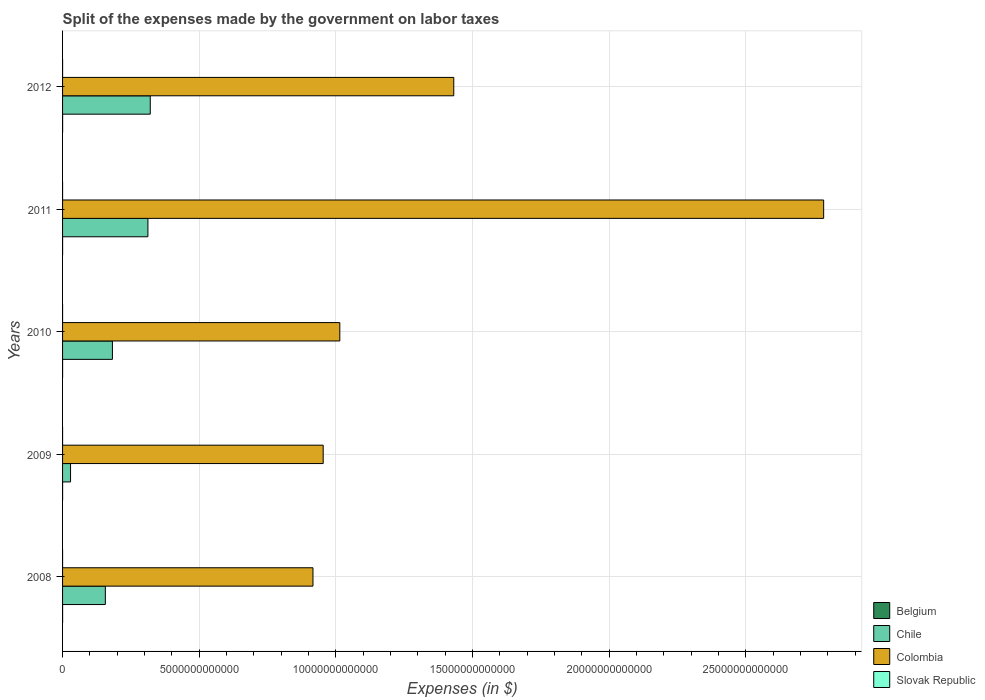Are the number of bars per tick equal to the number of legend labels?
Provide a short and direct response. Yes. Are the number of bars on each tick of the Y-axis equal?
Your response must be concise. Yes. How many bars are there on the 2nd tick from the bottom?
Make the answer very short. 4. What is the expenses made by the government on labor taxes in Chile in 2011?
Offer a very short reply. 3.12e+12. Across all years, what is the maximum expenses made by the government on labor taxes in Slovak Republic?
Your answer should be compact. 2.40e+08. Across all years, what is the minimum expenses made by the government on labor taxes in Slovak Republic?
Your answer should be very brief. 3.61e+05. In which year was the expenses made by the government on labor taxes in Slovak Republic minimum?
Make the answer very short. 2010. What is the total expenses made by the government on labor taxes in Colombia in the graph?
Offer a very short reply. 7.10e+13. What is the difference between the expenses made by the government on labor taxes in Belgium in 2009 and that in 2011?
Give a very brief answer. -1.00e+08. What is the difference between the expenses made by the government on labor taxes in Belgium in 2009 and the expenses made by the government on labor taxes in Colombia in 2011?
Offer a terse response. -2.78e+13. What is the average expenses made by the government on labor taxes in Slovak Republic per year?
Offer a terse response. 5.68e+07. In the year 2011, what is the difference between the expenses made by the government on labor taxes in Slovak Republic and expenses made by the government on labor taxes in Chile?
Make the answer very short. -3.12e+12. In how many years, is the expenses made by the government on labor taxes in Colombia greater than 2000000000000 $?
Your answer should be compact. 5. What is the ratio of the expenses made by the government on labor taxes in Colombia in 2008 to that in 2009?
Give a very brief answer. 0.96. Is the difference between the expenses made by the government on labor taxes in Slovak Republic in 2009 and 2010 greater than the difference between the expenses made by the government on labor taxes in Chile in 2009 and 2010?
Give a very brief answer. Yes. What is the difference between the highest and the second highest expenses made by the government on labor taxes in Colombia?
Offer a very short reply. 1.35e+13. What is the difference between the highest and the lowest expenses made by the government on labor taxes in Chile?
Your answer should be very brief. 2.92e+12. In how many years, is the expenses made by the government on labor taxes in Colombia greater than the average expenses made by the government on labor taxes in Colombia taken over all years?
Provide a succinct answer. 2. Is the sum of the expenses made by the government on labor taxes in Colombia in 2009 and 2010 greater than the maximum expenses made by the government on labor taxes in Slovak Republic across all years?
Offer a very short reply. Yes. Is it the case that in every year, the sum of the expenses made by the government on labor taxes in Slovak Republic and expenses made by the government on labor taxes in Colombia is greater than the sum of expenses made by the government on labor taxes in Belgium and expenses made by the government on labor taxes in Chile?
Your answer should be very brief. Yes. What does the 3rd bar from the top in 2011 represents?
Your response must be concise. Chile. Are all the bars in the graph horizontal?
Give a very brief answer. Yes. How many years are there in the graph?
Offer a terse response. 5. What is the difference between two consecutive major ticks on the X-axis?
Offer a very short reply. 5.00e+12. Are the values on the major ticks of X-axis written in scientific E-notation?
Your answer should be compact. No. How are the legend labels stacked?
Offer a very short reply. Vertical. What is the title of the graph?
Your answer should be compact. Split of the expenses made by the government on labor taxes. Does "United Kingdom" appear as one of the legend labels in the graph?
Provide a succinct answer. No. What is the label or title of the X-axis?
Your answer should be compact. Expenses (in $). What is the Expenses (in $) of Belgium in 2008?
Your response must be concise. 1.14e+09. What is the Expenses (in $) of Chile in 2008?
Ensure brevity in your answer.  1.57e+12. What is the Expenses (in $) in Colombia in 2008?
Keep it short and to the point. 9.16e+12. What is the Expenses (in $) of Slovak Republic in 2008?
Offer a terse response. 1.39e+06. What is the Expenses (in $) of Belgium in 2009?
Give a very brief answer. 1.05e+09. What is the Expenses (in $) of Chile in 2009?
Ensure brevity in your answer.  2.92e+11. What is the Expenses (in $) of Colombia in 2009?
Keep it short and to the point. 9.54e+12. What is the Expenses (in $) of Slovak Republic in 2009?
Keep it short and to the point. 7.25e+05. What is the Expenses (in $) in Belgium in 2010?
Your response must be concise. 1.13e+09. What is the Expenses (in $) in Chile in 2010?
Provide a succinct answer. 1.82e+12. What is the Expenses (in $) of Colombia in 2010?
Give a very brief answer. 1.01e+13. What is the Expenses (in $) in Slovak Republic in 2010?
Offer a terse response. 3.61e+05. What is the Expenses (in $) of Belgium in 2011?
Provide a succinct answer. 1.15e+09. What is the Expenses (in $) of Chile in 2011?
Your answer should be compact. 3.12e+12. What is the Expenses (in $) in Colombia in 2011?
Your answer should be compact. 2.78e+13. What is the Expenses (in $) in Slovak Republic in 2011?
Your response must be concise. 4.13e+07. What is the Expenses (in $) in Belgium in 2012?
Your response must be concise. 1.84e+09. What is the Expenses (in $) in Chile in 2012?
Your answer should be compact. 3.21e+12. What is the Expenses (in $) of Colombia in 2012?
Your answer should be very brief. 1.43e+13. What is the Expenses (in $) in Slovak Republic in 2012?
Offer a very short reply. 2.40e+08. Across all years, what is the maximum Expenses (in $) in Belgium?
Provide a succinct answer. 1.84e+09. Across all years, what is the maximum Expenses (in $) of Chile?
Offer a terse response. 3.21e+12. Across all years, what is the maximum Expenses (in $) of Colombia?
Ensure brevity in your answer.  2.78e+13. Across all years, what is the maximum Expenses (in $) in Slovak Republic?
Your response must be concise. 2.40e+08. Across all years, what is the minimum Expenses (in $) in Belgium?
Your answer should be very brief. 1.05e+09. Across all years, what is the minimum Expenses (in $) in Chile?
Your answer should be very brief. 2.92e+11. Across all years, what is the minimum Expenses (in $) of Colombia?
Your answer should be very brief. 9.16e+12. Across all years, what is the minimum Expenses (in $) of Slovak Republic?
Ensure brevity in your answer.  3.61e+05. What is the total Expenses (in $) of Belgium in the graph?
Offer a very short reply. 6.31e+09. What is the total Expenses (in $) of Chile in the graph?
Provide a short and direct response. 1.00e+13. What is the total Expenses (in $) of Colombia in the graph?
Provide a succinct answer. 7.10e+13. What is the total Expenses (in $) in Slovak Republic in the graph?
Your answer should be very brief. 2.84e+08. What is the difference between the Expenses (in $) of Belgium in 2008 and that in 2009?
Your response must be concise. 9.70e+07. What is the difference between the Expenses (in $) in Chile in 2008 and that in 2009?
Your response must be concise. 1.27e+12. What is the difference between the Expenses (in $) in Colombia in 2008 and that in 2009?
Your answer should be compact. -3.74e+11. What is the difference between the Expenses (in $) of Slovak Republic in 2008 and that in 2009?
Make the answer very short. 6.67e+05. What is the difference between the Expenses (in $) of Belgium in 2008 and that in 2010?
Your answer should be compact. 1.56e+07. What is the difference between the Expenses (in $) of Chile in 2008 and that in 2010?
Ensure brevity in your answer.  -2.59e+11. What is the difference between the Expenses (in $) in Colombia in 2008 and that in 2010?
Ensure brevity in your answer.  -9.82e+11. What is the difference between the Expenses (in $) in Slovak Republic in 2008 and that in 2010?
Your answer should be very brief. 1.03e+06. What is the difference between the Expenses (in $) of Belgium in 2008 and that in 2011?
Your answer should be very brief. -3.50e+06. What is the difference between the Expenses (in $) in Chile in 2008 and that in 2011?
Provide a succinct answer. -1.56e+12. What is the difference between the Expenses (in $) in Colombia in 2008 and that in 2011?
Keep it short and to the point. -1.87e+13. What is the difference between the Expenses (in $) in Slovak Republic in 2008 and that in 2011?
Keep it short and to the point. -3.99e+07. What is the difference between the Expenses (in $) of Belgium in 2008 and that in 2012?
Your answer should be very brief. -6.92e+08. What is the difference between the Expenses (in $) of Chile in 2008 and that in 2012?
Your answer should be compact. -1.64e+12. What is the difference between the Expenses (in $) of Colombia in 2008 and that in 2012?
Give a very brief answer. -5.15e+12. What is the difference between the Expenses (in $) in Slovak Republic in 2008 and that in 2012?
Your response must be concise. -2.39e+08. What is the difference between the Expenses (in $) in Belgium in 2009 and that in 2010?
Keep it short and to the point. -8.14e+07. What is the difference between the Expenses (in $) of Chile in 2009 and that in 2010?
Provide a succinct answer. -1.53e+12. What is the difference between the Expenses (in $) of Colombia in 2009 and that in 2010?
Provide a short and direct response. -6.08e+11. What is the difference between the Expenses (in $) in Slovak Republic in 2009 and that in 2010?
Ensure brevity in your answer.  3.64e+05. What is the difference between the Expenses (in $) of Belgium in 2009 and that in 2011?
Your answer should be compact. -1.00e+08. What is the difference between the Expenses (in $) of Chile in 2009 and that in 2011?
Provide a short and direct response. -2.83e+12. What is the difference between the Expenses (in $) in Colombia in 2009 and that in 2011?
Your answer should be very brief. -1.83e+13. What is the difference between the Expenses (in $) of Slovak Republic in 2009 and that in 2011?
Offer a very short reply. -4.06e+07. What is the difference between the Expenses (in $) in Belgium in 2009 and that in 2012?
Give a very brief answer. -7.89e+08. What is the difference between the Expenses (in $) in Chile in 2009 and that in 2012?
Keep it short and to the point. -2.92e+12. What is the difference between the Expenses (in $) of Colombia in 2009 and that in 2012?
Keep it short and to the point. -4.78e+12. What is the difference between the Expenses (in $) in Slovak Republic in 2009 and that in 2012?
Ensure brevity in your answer.  -2.40e+08. What is the difference between the Expenses (in $) of Belgium in 2010 and that in 2011?
Your answer should be very brief. -1.91e+07. What is the difference between the Expenses (in $) of Chile in 2010 and that in 2011?
Make the answer very short. -1.30e+12. What is the difference between the Expenses (in $) in Colombia in 2010 and that in 2011?
Give a very brief answer. -1.77e+13. What is the difference between the Expenses (in $) of Slovak Republic in 2010 and that in 2011?
Your response must be concise. -4.10e+07. What is the difference between the Expenses (in $) in Belgium in 2010 and that in 2012?
Provide a succinct answer. -7.08e+08. What is the difference between the Expenses (in $) in Chile in 2010 and that in 2012?
Your answer should be very brief. -1.38e+12. What is the difference between the Expenses (in $) in Colombia in 2010 and that in 2012?
Provide a short and direct response. -4.17e+12. What is the difference between the Expenses (in $) in Slovak Republic in 2010 and that in 2012?
Make the answer very short. -2.40e+08. What is the difference between the Expenses (in $) of Belgium in 2011 and that in 2012?
Your response must be concise. -6.89e+08. What is the difference between the Expenses (in $) in Chile in 2011 and that in 2012?
Keep it short and to the point. -8.61e+1. What is the difference between the Expenses (in $) in Colombia in 2011 and that in 2012?
Your response must be concise. 1.35e+13. What is the difference between the Expenses (in $) in Slovak Republic in 2011 and that in 2012?
Your answer should be compact. -1.99e+08. What is the difference between the Expenses (in $) of Belgium in 2008 and the Expenses (in $) of Chile in 2009?
Your answer should be compact. -2.91e+11. What is the difference between the Expenses (in $) in Belgium in 2008 and the Expenses (in $) in Colombia in 2009?
Your answer should be compact. -9.53e+12. What is the difference between the Expenses (in $) in Belgium in 2008 and the Expenses (in $) in Slovak Republic in 2009?
Offer a terse response. 1.14e+09. What is the difference between the Expenses (in $) of Chile in 2008 and the Expenses (in $) of Colombia in 2009?
Your response must be concise. -7.97e+12. What is the difference between the Expenses (in $) in Chile in 2008 and the Expenses (in $) in Slovak Republic in 2009?
Offer a very short reply. 1.57e+12. What is the difference between the Expenses (in $) of Colombia in 2008 and the Expenses (in $) of Slovak Republic in 2009?
Provide a short and direct response. 9.16e+12. What is the difference between the Expenses (in $) in Belgium in 2008 and the Expenses (in $) in Chile in 2010?
Your answer should be compact. -1.82e+12. What is the difference between the Expenses (in $) in Belgium in 2008 and the Expenses (in $) in Colombia in 2010?
Offer a very short reply. -1.01e+13. What is the difference between the Expenses (in $) of Belgium in 2008 and the Expenses (in $) of Slovak Republic in 2010?
Keep it short and to the point. 1.14e+09. What is the difference between the Expenses (in $) in Chile in 2008 and the Expenses (in $) in Colombia in 2010?
Make the answer very short. -8.58e+12. What is the difference between the Expenses (in $) in Chile in 2008 and the Expenses (in $) in Slovak Republic in 2010?
Keep it short and to the point. 1.57e+12. What is the difference between the Expenses (in $) of Colombia in 2008 and the Expenses (in $) of Slovak Republic in 2010?
Ensure brevity in your answer.  9.16e+12. What is the difference between the Expenses (in $) of Belgium in 2008 and the Expenses (in $) of Chile in 2011?
Keep it short and to the point. -3.12e+12. What is the difference between the Expenses (in $) in Belgium in 2008 and the Expenses (in $) in Colombia in 2011?
Your answer should be compact. -2.78e+13. What is the difference between the Expenses (in $) in Belgium in 2008 and the Expenses (in $) in Slovak Republic in 2011?
Your answer should be very brief. 1.10e+09. What is the difference between the Expenses (in $) of Chile in 2008 and the Expenses (in $) of Colombia in 2011?
Offer a terse response. -2.63e+13. What is the difference between the Expenses (in $) in Chile in 2008 and the Expenses (in $) in Slovak Republic in 2011?
Make the answer very short. 1.57e+12. What is the difference between the Expenses (in $) in Colombia in 2008 and the Expenses (in $) in Slovak Republic in 2011?
Your answer should be very brief. 9.16e+12. What is the difference between the Expenses (in $) of Belgium in 2008 and the Expenses (in $) of Chile in 2012?
Your response must be concise. -3.21e+12. What is the difference between the Expenses (in $) in Belgium in 2008 and the Expenses (in $) in Colombia in 2012?
Offer a terse response. -1.43e+13. What is the difference between the Expenses (in $) of Belgium in 2008 and the Expenses (in $) of Slovak Republic in 2012?
Provide a succinct answer. 9.04e+08. What is the difference between the Expenses (in $) of Chile in 2008 and the Expenses (in $) of Colombia in 2012?
Offer a very short reply. -1.27e+13. What is the difference between the Expenses (in $) of Chile in 2008 and the Expenses (in $) of Slovak Republic in 2012?
Your answer should be compact. 1.56e+12. What is the difference between the Expenses (in $) in Colombia in 2008 and the Expenses (in $) in Slovak Republic in 2012?
Offer a very short reply. 9.16e+12. What is the difference between the Expenses (in $) of Belgium in 2009 and the Expenses (in $) of Chile in 2010?
Make the answer very short. -1.82e+12. What is the difference between the Expenses (in $) of Belgium in 2009 and the Expenses (in $) of Colombia in 2010?
Give a very brief answer. -1.01e+13. What is the difference between the Expenses (in $) in Belgium in 2009 and the Expenses (in $) in Slovak Republic in 2010?
Offer a very short reply. 1.05e+09. What is the difference between the Expenses (in $) of Chile in 2009 and the Expenses (in $) of Colombia in 2010?
Your answer should be very brief. -9.85e+12. What is the difference between the Expenses (in $) of Chile in 2009 and the Expenses (in $) of Slovak Republic in 2010?
Give a very brief answer. 2.92e+11. What is the difference between the Expenses (in $) of Colombia in 2009 and the Expenses (in $) of Slovak Republic in 2010?
Your response must be concise. 9.54e+12. What is the difference between the Expenses (in $) of Belgium in 2009 and the Expenses (in $) of Chile in 2011?
Provide a short and direct response. -3.12e+12. What is the difference between the Expenses (in $) of Belgium in 2009 and the Expenses (in $) of Colombia in 2011?
Offer a terse response. -2.78e+13. What is the difference between the Expenses (in $) in Belgium in 2009 and the Expenses (in $) in Slovak Republic in 2011?
Your response must be concise. 1.01e+09. What is the difference between the Expenses (in $) of Chile in 2009 and the Expenses (in $) of Colombia in 2011?
Your answer should be compact. -2.76e+13. What is the difference between the Expenses (in $) of Chile in 2009 and the Expenses (in $) of Slovak Republic in 2011?
Make the answer very short. 2.92e+11. What is the difference between the Expenses (in $) of Colombia in 2009 and the Expenses (in $) of Slovak Republic in 2011?
Offer a terse response. 9.54e+12. What is the difference between the Expenses (in $) in Belgium in 2009 and the Expenses (in $) in Chile in 2012?
Provide a succinct answer. -3.21e+12. What is the difference between the Expenses (in $) of Belgium in 2009 and the Expenses (in $) of Colombia in 2012?
Make the answer very short. -1.43e+13. What is the difference between the Expenses (in $) of Belgium in 2009 and the Expenses (in $) of Slovak Republic in 2012?
Provide a succinct answer. 8.07e+08. What is the difference between the Expenses (in $) of Chile in 2009 and the Expenses (in $) of Colombia in 2012?
Provide a short and direct response. -1.40e+13. What is the difference between the Expenses (in $) in Chile in 2009 and the Expenses (in $) in Slovak Republic in 2012?
Give a very brief answer. 2.92e+11. What is the difference between the Expenses (in $) in Colombia in 2009 and the Expenses (in $) in Slovak Republic in 2012?
Your response must be concise. 9.54e+12. What is the difference between the Expenses (in $) in Belgium in 2010 and the Expenses (in $) in Chile in 2011?
Make the answer very short. -3.12e+12. What is the difference between the Expenses (in $) of Belgium in 2010 and the Expenses (in $) of Colombia in 2011?
Offer a very short reply. -2.78e+13. What is the difference between the Expenses (in $) of Belgium in 2010 and the Expenses (in $) of Slovak Republic in 2011?
Your response must be concise. 1.09e+09. What is the difference between the Expenses (in $) of Chile in 2010 and the Expenses (in $) of Colombia in 2011?
Offer a very short reply. -2.60e+13. What is the difference between the Expenses (in $) of Chile in 2010 and the Expenses (in $) of Slovak Republic in 2011?
Your answer should be very brief. 1.82e+12. What is the difference between the Expenses (in $) of Colombia in 2010 and the Expenses (in $) of Slovak Republic in 2011?
Give a very brief answer. 1.01e+13. What is the difference between the Expenses (in $) of Belgium in 2010 and the Expenses (in $) of Chile in 2012?
Your answer should be very brief. -3.21e+12. What is the difference between the Expenses (in $) in Belgium in 2010 and the Expenses (in $) in Colombia in 2012?
Your answer should be compact. -1.43e+13. What is the difference between the Expenses (in $) of Belgium in 2010 and the Expenses (in $) of Slovak Republic in 2012?
Your answer should be compact. 8.89e+08. What is the difference between the Expenses (in $) in Chile in 2010 and the Expenses (in $) in Colombia in 2012?
Make the answer very short. -1.25e+13. What is the difference between the Expenses (in $) in Chile in 2010 and the Expenses (in $) in Slovak Republic in 2012?
Your answer should be very brief. 1.82e+12. What is the difference between the Expenses (in $) in Colombia in 2010 and the Expenses (in $) in Slovak Republic in 2012?
Offer a very short reply. 1.01e+13. What is the difference between the Expenses (in $) of Belgium in 2011 and the Expenses (in $) of Chile in 2012?
Your response must be concise. -3.21e+12. What is the difference between the Expenses (in $) of Belgium in 2011 and the Expenses (in $) of Colombia in 2012?
Make the answer very short. -1.43e+13. What is the difference between the Expenses (in $) of Belgium in 2011 and the Expenses (in $) of Slovak Republic in 2012?
Provide a succinct answer. 9.08e+08. What is the difference between the Expenses (in $) of Chile in 2011 and the Expenses (in $) of Colombia in 2012?
Your response must be concise. -1.12e+13. What is the difference between the Expenses (in $) in Chile in 2011 and the Expenses (in $) in Slovak Republic in 2012?
Offer a very short reply. 3.12e+12. What is the difference between the Expenses (in $) in Colombia in 2011 and the Expenses (in $) in Slovak Republic in 2012?
Give a very brief answer. 2.78e+13. What is the average Expenses (in $) in Belgium per year?
Your answer should be very brief. 1.26e+09. What is the average Expenses (in $) of Chile per year?
Provide a succinct answer. 2.00e+12. What is the average Expenses (in $) of Colombia per year?
Your answer should be compact. 1.42e+13. What is the average Expenses (in $) of Slovak Republic per year?
Provide a short and direct response. 5.68e+07. In the year 2008, what is the difference between the Expenses (in $) of Belgium and Expenses (in $) of Chile?
Keep it short and to the point. -1.56e+12. In the year 2008, what is the difference between the Expenses (in $) of Belgium and Expenses (in $) of Colombia?
Provide a succinct answer. -9.16e+12. In the year 2008, what is the difference between the Expenses (in $) of Belgium and Expenses (in $) of Slovak Republic?
Offer a terse response. 1.14e+09. In the year 2008, what is the difference between the Expenses (in $) in Chile and Expenses (in $) in Colombia?
Offer a very short reply. -7.60e+12. In the year 2008, what is the difference between the Expenses (in $) in Chile and Expenses (in $) in Slovak Republic?
Provide a short and direct response. 1.57e+12. In the year 2008, what is the difference between the Expenses (in $) of Colombia and Expenses (in $) of Slovak Republic?
Your response must be concise. 9.16e+12. In the year 2009, what is the difference between the Expenses (in $) in Belgium and Expenses (in $) in Chile?
Your response must be concise. -2.91e+11. In the year 2009, what is the difference between the Expenses (in $) in Belgium and Expenses (in $) in Colombia?
Ensure brevity in your answer.  -9.54e+12. In the year 2009, what is the difference between the Expenses (in $) in Belgium and Expenses (in $) in Slovak Republic?
Give a very brief answer. 1.05e+09. In the year 2009, what is the difference between the Expenses (in $) in Chile and Expenses (in $) in Colombia?
Give a very brief answer. -9.24e+12. In the year 2009, what is the difference between the Expenses (in $) in Chile and Expenses (in $) in Slovak Republic?
Your response must be concise. 2.92e+11. In the year 2009, what is the difference between the Expenses (in $) of Colombia and Expenses (in $) of Slovak Republic?
Make the answer very short. 9.54e+12. In the year 2010, what is the difference between the Expenses (in $) of Belgium and Expenses (in $) of Chile?
Provide a succinct answer. -1.82e+12. In the year 2010, what is the difference between the Expenses (in $) of Belgium and Expenses (in $) of Colombia?
Provide a succinct answer. -1.01e+13. In the year 2010, what is the difference between the Expenses (in $) in Belgium and Expenses (in $) in Slovak Republic?
Offer a very short reply. 1.13e+09. In the year 2010, what is the difference between the Expenses (in $) in Chile and Expenses (in $) in Colombia?
Your answer should be very brief. -8.32e+12. In the year 2010, what is the difference between the Expenses (in $) of Chile and Expenses (in $) of Slovak Republic?
Your response must be concise. 1.82e+12. In the year 2010, what is the difference between the Expenses (in $) of Colombia and Expenses (in $) of Slovak Republic?
Make the answer very short. 1.01e+13. In the year 2011, what is the difference between the Expenses (in $) of Belgium and Expenses (in $) of Chile?
Your answer should be very brief. -3.12e+12. In the year 2011, what is the difference between the Expenses (in $) of Belgium and Expenses (in $) of Colombia?
Offer a very short reply. -2.78e+13. In the year 2011, what is the difference between the Expenses (in $) in Belgium and Expenses (in $) in Slovak Republic?
Your answer should be very brief. 1.11e+09. In the year 2011, what is the difference between the Expenses (in $) of Chile and Expenses (in $) of Colombia?
Your response must be concise. -2.47e+13. In the year 2011, what is the difference between the Expenses (in $) in Chile and Expenses (in $) in Slovak Republic?
Make the answer very short. 3.12e+12. In the year 2011, what is the difference between the Expenses (in $) in Colombia and Expenses (in $) in Slovak Republic?
Ensure brevity in your answer.  2.78e+13. In the year 2012, what is the difference between the Expenses (in $) of Belgium and Expenses (in $) of Chile?
Your answer should be compact. -3.21e+12. In the year 2012, what is the difference between the Expenses (in $) of Belgium and Expenses (in $) of Colombia?
Provide a short and direct response. -1.43e+13. In the year 2012, what is the difference between the Expenses (in $) of Belgium and Expenses (in $) of Slovak Republic?
Your response must be concise. 1.60e+09. In the year 2012, what is the difference between the Expenses (in $) of Chile and Expenses (in $) of Colombia?
Give a very brief answer. -1.11e+13. In the year 2012, what is the difference between the Expenses (in $) in Chile and Expenses (in $) in Slovak Republic?
Offer a very short reply. 3.21e+12. In the year 2012, what is the difference between the Expenses (in $) in Colombia and Expenses (in $) in Slovak Republic?
Your answer should be very brief. 1.43e+13. What is the ratio of the Expenses (in $) of Belgium in 2008 to that in 2009?
Keep it short and to the point. 1.09. What is the ratio of the Expenses (in $) of Chile in 2008 to that in 2009?
Offer a terse response. 5.35. What is the ratio of the Expenses (in $) of Colombia in 2008 to that in 2009?
Keep it short and to the point. 0.96. What is the ratio of the Expenses (in $) of Slovak Republic in 2008 to that in 2009?
Offer a terse response. 1.92. What is the ratio of the Expenses (in $) of Belgium in 2008 to that in 2010?
Your answer should be very brief. 1.01. What is the ratio of the Expenses (in $) in Chile in 2008 to that in 2010?
Offer a very short reply. 0.86. What is the ratio of the Expenses (in $) of Colombia in 2008 to that in 2010?
Offer a terse response. 0.9. What is the ratio of the Expenses (in $) of Slovak Republic in 2008 to that in 2010?
Offer a terse response. 3.85. What is the ratio of the Expenses (in $) in Belgium in 2008 to that in 2011?
Ensure brevity in your answer.  1. What is the ratio of the Expenses (in $) of Chile in 2008 to that in 2011?
Ensure brevity in your answer.  0.5. What is the ratio of the Expenses (in $) in Colombia in 2008 to that in 2011?
Give a very brief answer. 0.33. What is the ratio of the Expenses (in $) of Slovak Republic in 2008 to that in 2011?
Give a very brief answer. 0.03. What is the ratio of the Expenses (in $) of Belgium in 2008 to that in 2012?
Offer a terse response. 0.62. What is the ratio of the Expenses (in $) of Chile in 2008 to that in 2012?
Your answer should be compact. 0.49. What is the ratio of the Expenses (in $) in Colombia in 2008 to that in 2012?
Offer a terse response. 0.64. What is the ratio of the Expenses (in $) of Slovak Republic in 2008 to that in 2012?
Ensure brevity in your answer.  0.01. What is the ratio of the Expenses (in $) of Belgium in 2009 to that in 2010?
Your answer should be compact. 0.93. What is the ratio of the Expenses (in $) in Chile in 2009 to that in 2010?
Your answer should be very brief. 0.16. What is the ratio of the Expenses (in $) in Colombia in 2009 to that in 2010?
Provide a short and direct response. 0.94. What is the ratio of the Expenses (in $) in Slovak Republic in 2009 to that in 2010?
Make the answer very short. 2.01. What is the ratio of the Expenses (in $) in Belgium in 2009 to that in 2011?
Your answer should be compact. 0.91. What is the ratio of the Expenses (in $) of Chile in 2009 to that in 2011?
Keep it short and to the point. 0.09. What is the ratio of the Expenses (in $) in Colombia in 2009 to that in 2011?
Your answer should be very brief. 0.34. What is the ratio of the Expenses (in $) in Slovak Republic in 2009 to that in 2011?
Provide a short and direct response. 0.02. What is the ratio of the Expenses (in $) in Belgium in 2009 to that in 2012?
Make the answer very short. 0.57. What is the ratio of the Expenses (in $) of Chile in 2009 to that in 2012?
Ensure brevity in your answer.  0.09. What is the ratio of the Expenses (in $) in Colombia in 2009 to that in 2012?
Keep it short and to the point. 0.67. What is the ratio of the Expenses (in $) of Slovak Republic in 2009 to that in 2012?
Your response must be concise. 0. What is the ratio of the Expenses (in $) in Belgium in 2010 to that in 2011?
Your response must be concise. 0.98. What is the ratio of the Expenses (in $) in Chile in 2010 to that in 2011?
Offer a terse response. 0.58. What is the ratio of the Expenses (in $) of Colombia in 2010 to that in 2011?
Provide a short and direct response. 0.36. What is the ratio of the Expenses (in $) of Slovak Republic in 2010 to that in 2011?
Your answer should be very brief. 0.01. What is the ratio of the Expenses (in $) in Belgium in 2010 to that in 2012?
Your answer should be very brief. 0.61. What is the ratio of the Expenses (in $) in Chile in 2010 to that in 2012?
Ensure brevity in your answer.  0.57. What is the ratio of the Expenses (in $) of Colombia in 2010 to that in 2012?
Your answer should be compact. 0.71. What is the ratio of the Expenses (in $) of Slovak Republic in 2010 to that in 2012?
Offer a very short reply. 0. What is the ratio of the Expenses (in $) in Chile in 2011 to that in 2012?
Give a very brief answer. 0.97. What is the ratio of the Expenses (in $) in Colombia in 2011 to that in 2012?
Keep it short and to the point. 1.95. What is the ratio of the Expenses (in $) in Slovak Republic in 2011 to that in 2012?
Keep it short and to the point. 0.17. What is the difference between the highest and the second highest Expenses (in $) in Belgium?
Offer a very short reply. 6.89e+08. What is the difference between the highest and the second highest Expenses (in $) of Chile?
Provide a short and direct response. 8.61e+1. What is the difference between the highest and the second highest Expenses (in $) of Colombia?
Provide a succinct answer. 1.35e+13. What is the difference between the highest and the second highest Expenses (in $) in Slovak Republic?
Provide a short and direct response. 1.99e+08. What is the difference between the highest and the lowest Expenses (in $) of Belgium?
Your answer should be very brief. 7.89e+08. What is the difference between the highest and the lowest Expenses (in $) of Chile?
Your answer should be very brief. 2.92e+12. What is the difference between the highest and the lowest Expenses (in $) of Colombia?
Ensure brevity in your answer.  1.87e+13. What is the difference between the highest and the lowest Expenses (in $) of Slovak Republic?
Make the answer very short. 2.40e+08. 